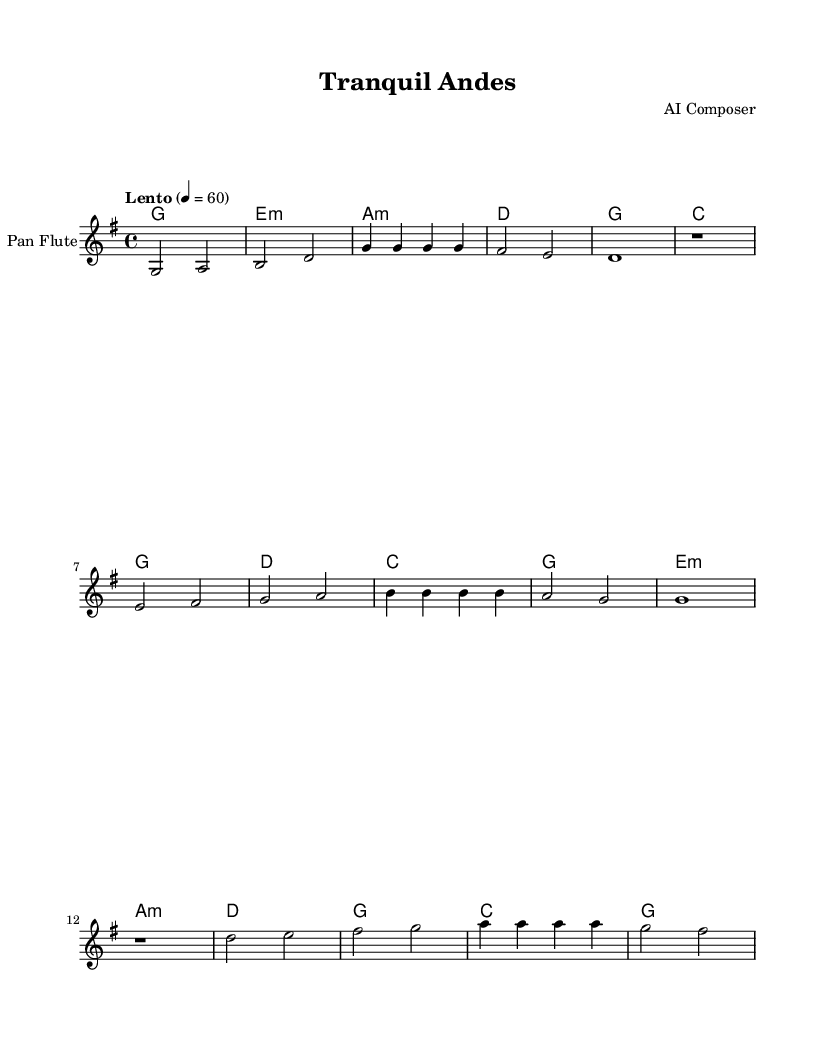What is the key signature of this music? The key signature is G major, which has one sharp (F#). You can identify the key signature by looking at the clef at the beginning of the staff where the sharps are indicated on the staff lines or spaces.
Answer: G major What is the time signature? The time signature is 4/4, which means there are 4 beats in each measure, and each quarter note gets one beat. This is seen at the beginning of the staff next to the key signature.
Answer: 4/4 What is the tempo marking? The tempo marking is "Lento," which indicates a slow speed. This is specified at the start of the music sheet and suggests a relaxed and tranquil pace for the piece.
Answer: Lento How many measures are in the melody section? The melody section has 12 measures. By counting each segment of music between the bar lines, you can calculate the total number of measures.
Answer: 12 What is the last note of the melody? The last note of the melody is G. You can find this by looking at the final pitch in the last measure of the melody, observing that it corresponds to a G note.
Answer: G What type of instrument is specified in the staff? The instrument specified is a "Pan Flute." This is indicated in the staff label at the beginning of the music sheet.
Answer: Pan Flute What is the first harmony chord in the score? The first harmony chord is G major. This is evident from the chord names written above the melody at the start of the score.
Answer: G major 